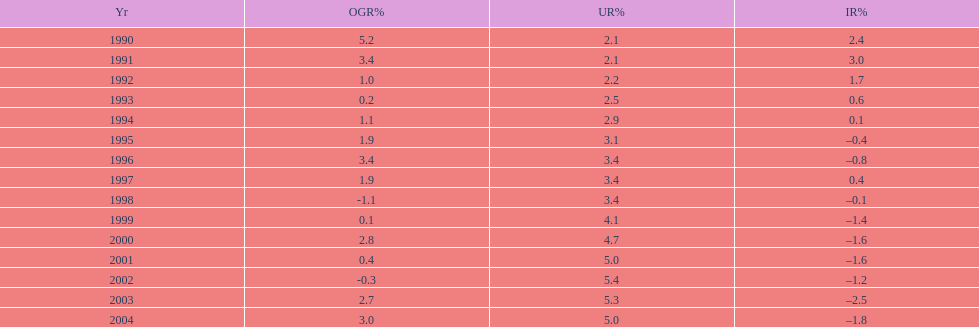What year had the highest unemployment rate? 2002. 